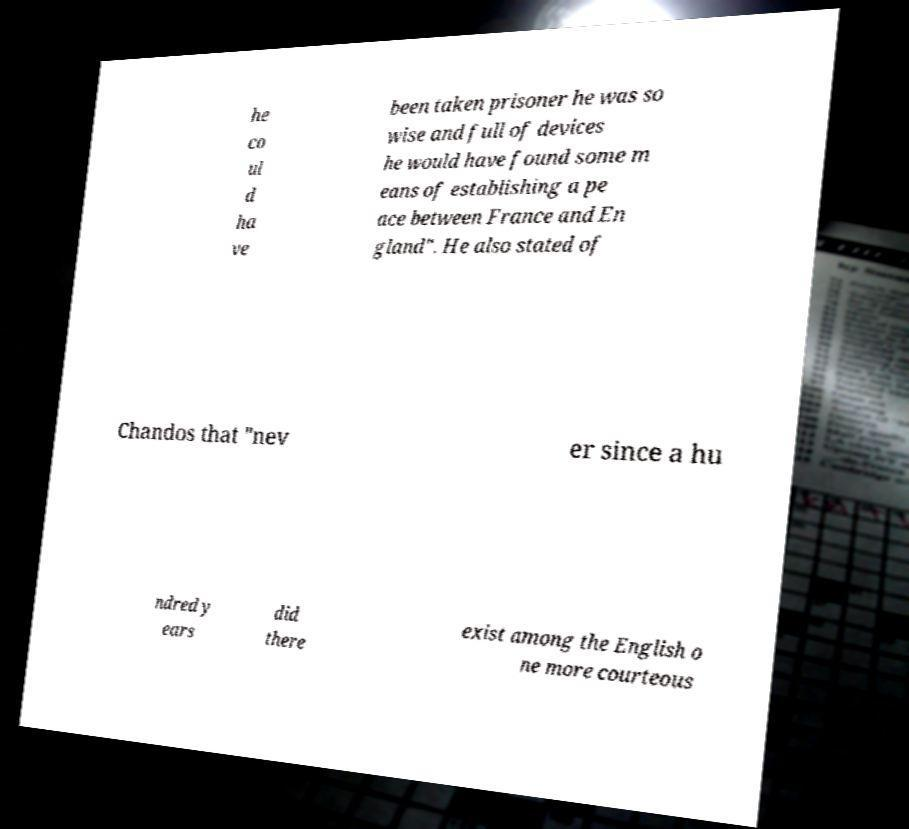Please identify and transcribe the text found in this image. he co ul d ha ve been taken prisoner he was so wise and full of devices he would have found some m eans of establishing a pe ace between France and En gland". He also stated of Chandos that "nev er since a hu ndred y ears did there exist among the English o ne more courteous 